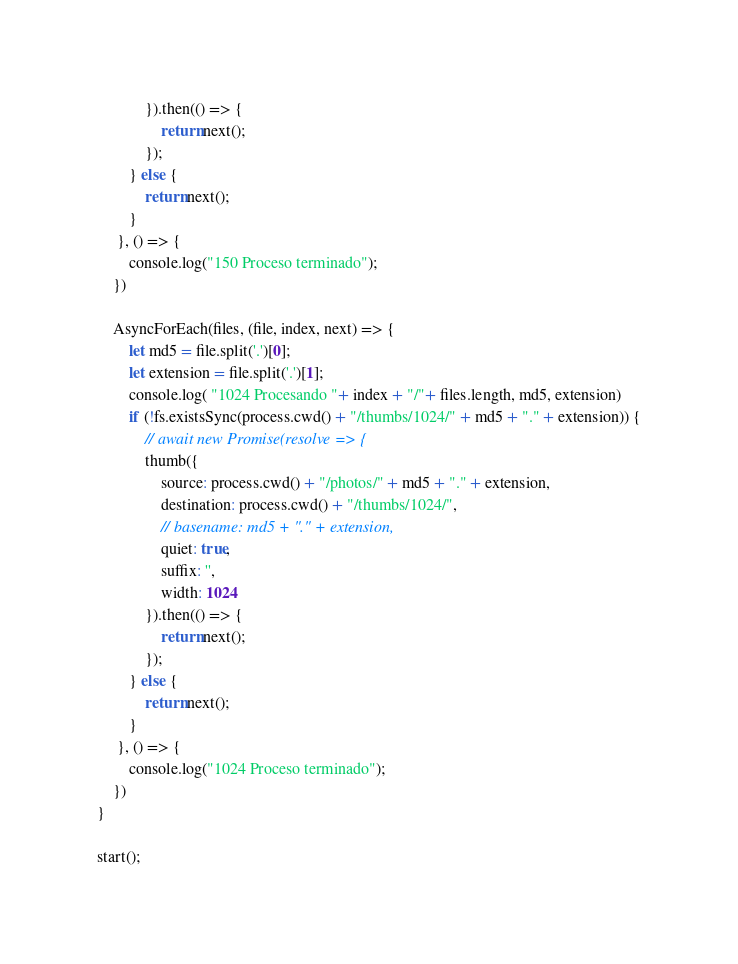<code> <loc_0><loc_0><loc_500><loc_500><_JavaScript_>			}).then(() => {
				return next();
			});
		} else {
			return next();
		}
	 }, () => {
		console.log("150 Proceso terminado");
	})

	AsyncForEach(files, (file, index, next) => {
		let md5 = file.split('.')[0];
		let extension = file.split('.')[1];
		console.log( "1024 Procesando "+ index + "/"+ files.length, md5, extension)
		if (!fs.existsSync(process.cwd() + "/thumbs/1024/" + md5 + "." + extension)) {
			// await new Promise(resolve => {
			thumb({
				source: process.cwd() + "/photos/" + md5 + "." + extension,
				destination: process.cwd() + "/thumbs/1024/",
				// basename: md5 + "." + extension,
				quiet: true,
				suffix: '',
				width: 1024
			}).then(() => {
				return next();
			});
		} else {
			return next();
		}
	 }, () => {
		console.log("1024 Proceso terminado");
	})
}

start();
</code> 